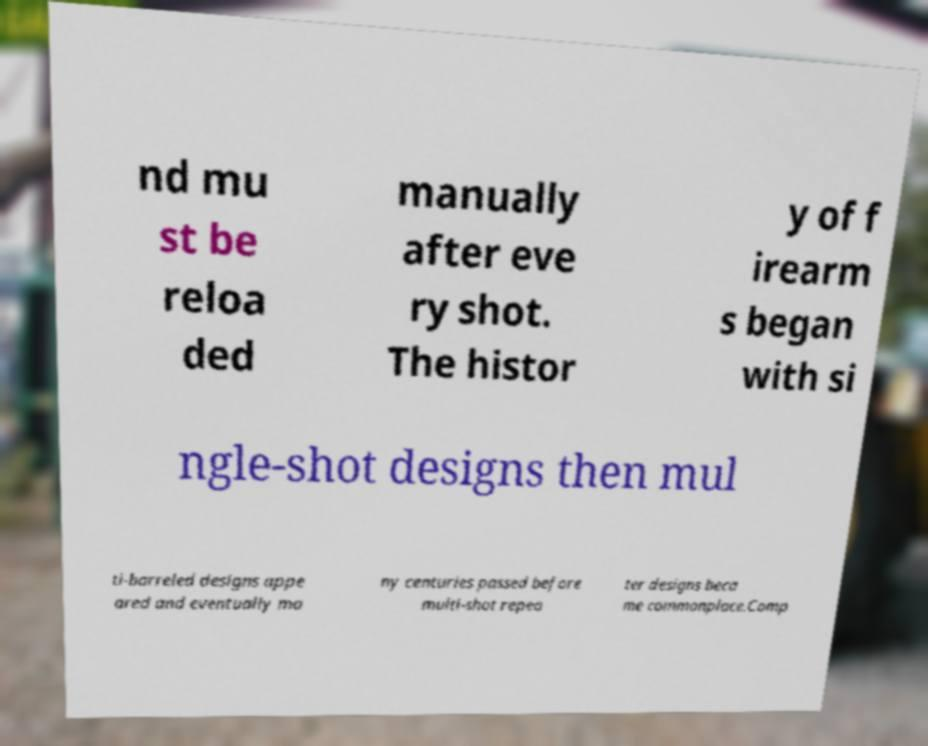Could you extract and type out the text from this image? nd mu st be reloa ded manually after eve ry shot. The histor y of f irearm s began with si ngle-shot designs then mul ti-barreled designs appe ared and eventually ma ny centuries passed before multi-shot repea ter designs beca me commonplace.Comp 